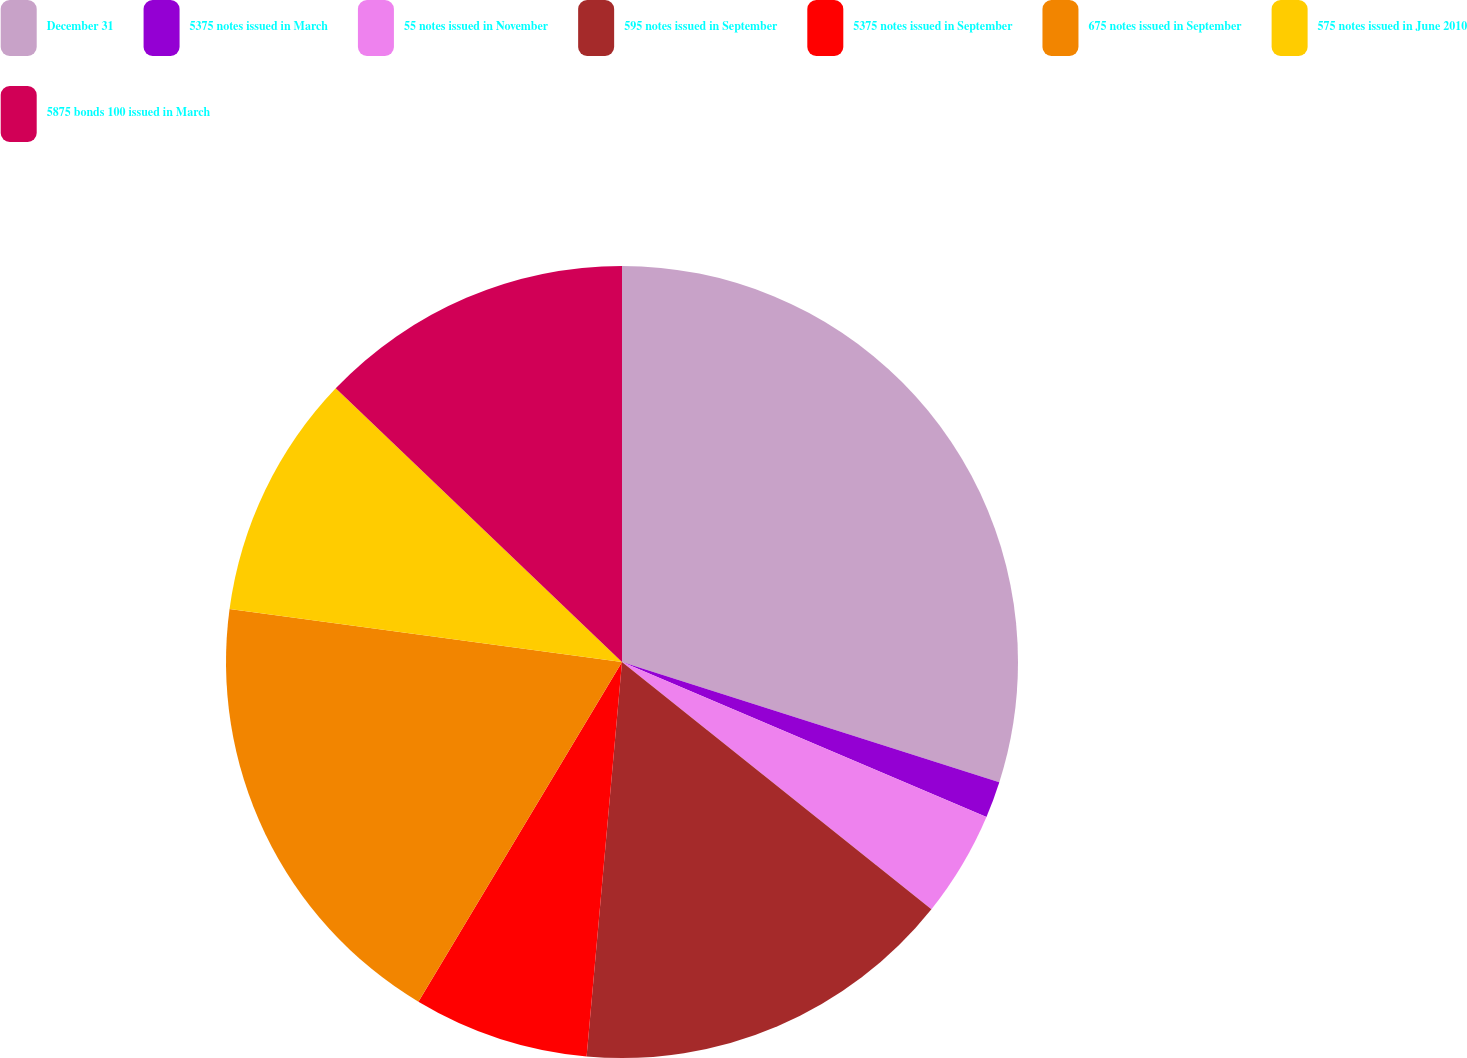Convert chart to OTSL. <chart><loc_0><loc_0><loc_500><loc_500><pie_chart><fcel>December 31<fcel>5375 notes issued in March<fcel>55 notes issued in November<fcel>595 notes issued in September<fcel>5375 notes issued in September<fcel>675 notes issued in September<fcel>575 notes issued in June 2010<fcel>5875 bonds 100 issued in March<nl><fcel>29.91%<fcel>1.49%<fcel>4.33%<fcel>15.7%<fcel>7.17%<fcel>18.54%<fcel>10.01%<fcel>12.86%<nl></chart> 